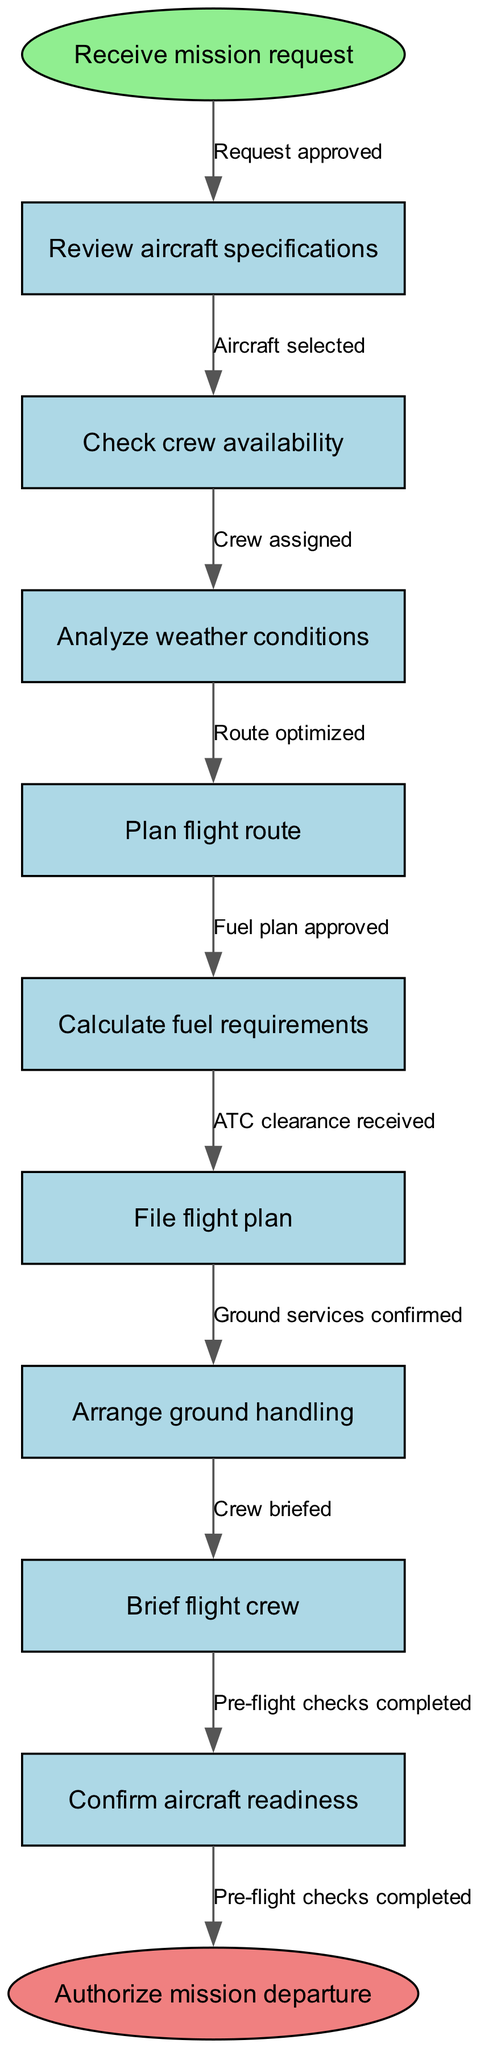What is the first step in the flight planning process? The diagram indicates the first step is "Receive mission request," which is the starting point in the process.
Answer: Receive mission request How many nodes are there in the diagram? By counting the nodes, we find there are a total of 9 process nodes present, plus the start and end nodes, resulting in 11 nodes overall.
Answer: 11 What does the last process before mission departure involve? The last process before the mission departure is "Pre-flight checks completed," which is the final step in the flow before authorizing the mission.
Answer: Pre-flight checks completed Which node follows "Check crew availability"? The node that follows "Check crew availability" is "Analyze weather conditions," indicating the sequence of operations in the flight planning process.
Answer: Analyze weather conditions What edge connects "Plan flight route" and "Calculate fuel requirements"? The edge that connects these two nodes is labeled "Route optimized," signifying that the route planning influences fuel calculations.
Answer: Route optimized What must be confirmed before the mission can depart? Before the mission can depart, it is necessary to confirm "aircraft readiness," as indicated by the flow of the diagram showing its importance in the planning process.
Answer: Confirm aircraft readiness How many edges are present in the diagram? Counting the edges shows there are a total of 9 edges connecting the nodes, which illustrate the flow of the process.
Answer: 9 What action must occur immediately after "File flight plan"? The action that must occur immediately after "File flight plan" is receiving "ATC clearance," indicating its necessity for proceeding with the flight.
Answer: ATC clearance received What is the purpose of the "Brief flight crew" step? The purpose of "Brief flight crew" is to prepare the crew with necessary information and ensure they are ready for the mission prior to departure.
Answer: Prepare the crew 